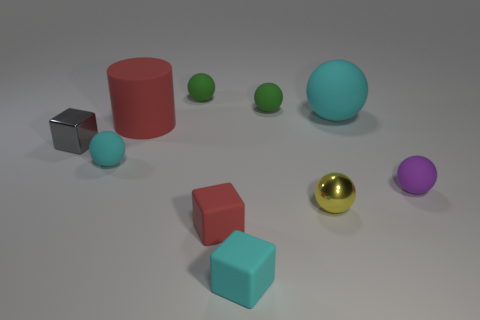Can you describe the layout of the shapes presented in the image? Certainly, the image displays an assortment of geometric shapes laid out on a flat surface. There are two cubes, one red and one teal, along with a small gray cube. Additionally, we see a cylindrical shape in red and a variety of spheres in different colors and sizes, one of which has a glossy golden texture. Do any of these shapes have a texture or color that stands out? Yes, the golden sphere catches the eye with its reflective, shiny surface, contrasting with the predominantly matte textures of the other objects. This sphere's vivid color and luster make it a focal point in the composition. 